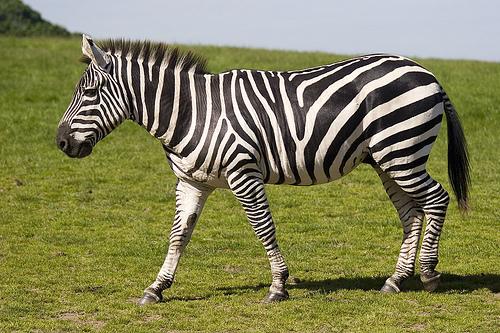Is the zebra in the sand?
Write a very short answer. No. How many zebras are there?
Quick response, please. 1. Where do zebras live?
Short answer required. Africa. What is the zebra doing?
Concise answer only. Walking. What kind of animal is drinking water?
Be succinct. Zebra. Is the zebra running?
Keep it brief. No. What color is the zebra's nose?
Write a very short answer. Black. 